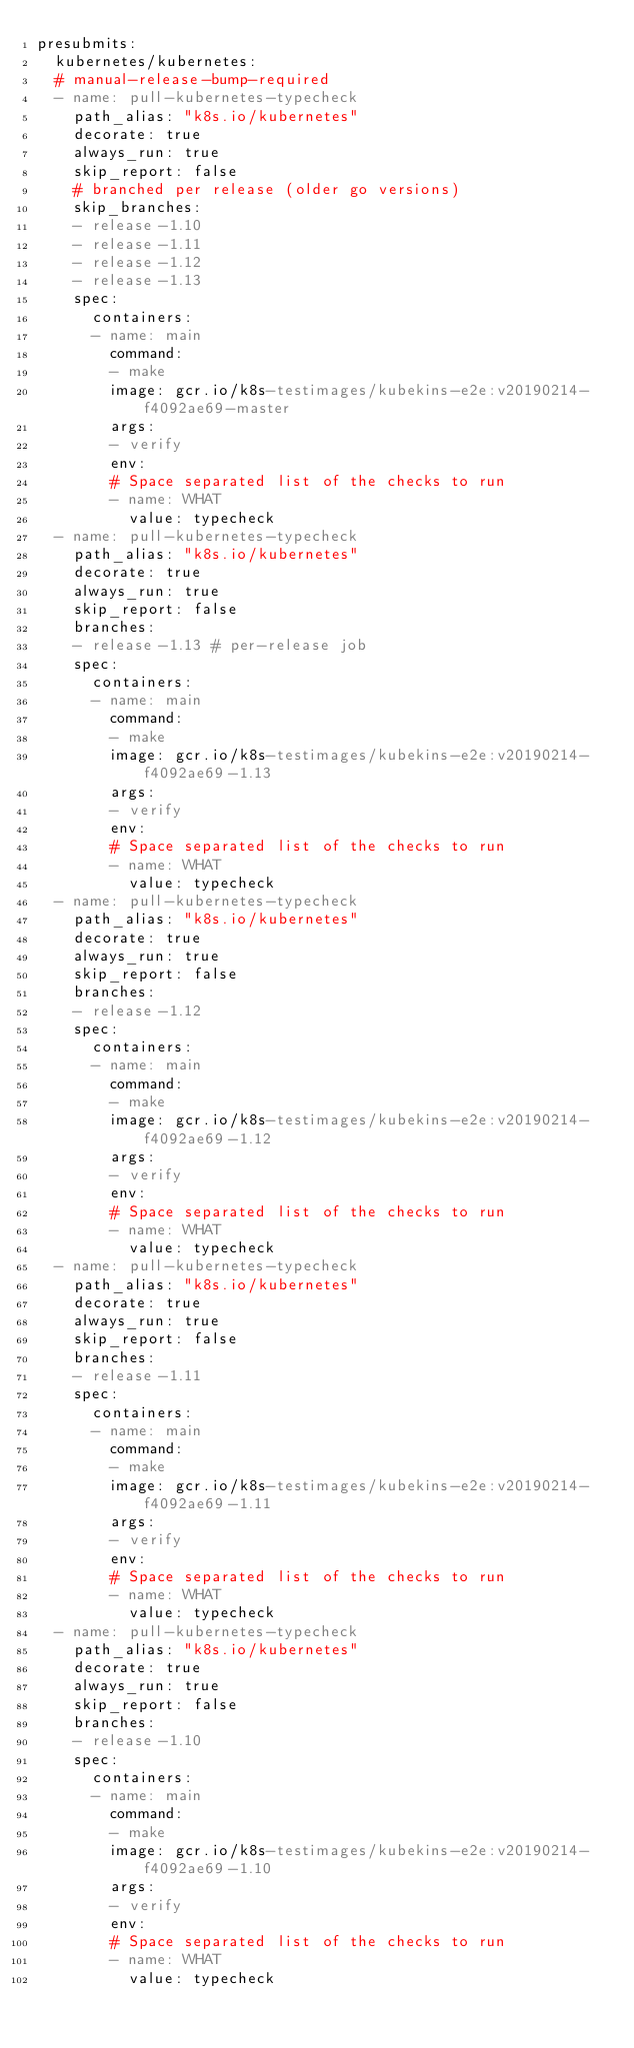Convert code to text. <code><loc_0><loc_0><loc_500><loc_500><_YAML_>presubmits:
  kubernetes/kubernetes:
  # manual-release-bump-required
  - name: pull-kubernetes-typecheck
    path_alias: "k8s.io/kubernetes"
    decorate: true
    always_run: true
    skip_report: false
    # branched per release (older go versions)
    skip_branches:
    - release-1.10
    - release-1.11
    - release-1.12
    - release-1.13
    spec:
      containers:
      - name: main
        command:
        - make
        image: gcr.io/k8s-testimages/kubekins-e2e:v20190214-f4092ae69-master
        args:
        - verify
        env:
        # Space separated list of the checks to run
        - name: WHAT
          value: typecheck
  - name: pull-kubernetes-typecheck
    path_alias: "k8s.io/kubernetes"
    decorate: true
    always_run: true
    skip_report: false
    branches:
    - release-1.13 # per-release job
    spec:
      containers:
      - name: main
        command:
        - make
        image: gcr.io/k8s-testimages/kubekins-e2e:v20190214-f4092ae69-1.13
        args:
        - verify
        env:
        # Space separated list of the checks to run
        - name: WHAT
          value: typecheck
  - name: pull-kubernetes-typecheck
    path_alias: "k8s.io/kubernetes"
    decorate: true
    always_run: true
    skip_report: false
    branches:
    - release-1.12
    spec:
      containers:
      - name: main
        command:
        - make
        image: gcr.io/k8s-testimages/kubekins-e2e:v20190214-f4092ae69-1.12
        args:
        - verify
        env:
        # Space separated list of the checks to run
        - name: WHAT
          value: typecheck
  - name: pull-kubernetes-typecheck
    path_alias: "k8s.io/kubernetes"
    decorate: true
    always_run: true
    skip_report: false
    branches:
    - release-1.11
    spec:
      containers:
      - name: main
        command:
        - make
        image: gcr.io/k8s-testimages/kubekins-e2e:v20190214-f4092ae69-1.11
        args:
        - verify
        env:
        # Space separated list of the checks to run
        - name: WHAT
          value: typecheck
  - name: pull-kubernetes-typecheck
    path_alias: "k8s.io/kubernetes"
    decorate: true
    always_run: true
    skip_report: false
    branches:
    - release-1.10
    spec:
      containers:
      - name: main
        command:
        - make
        image: gcr.io/k8s-testimages/kubekins-e2e:v20190214-f4092ae69-1.10
        args:
        - verify
        env:
        # Space separated list of the checks to run
        - name: WHAT
          value: typecheck

</code> 